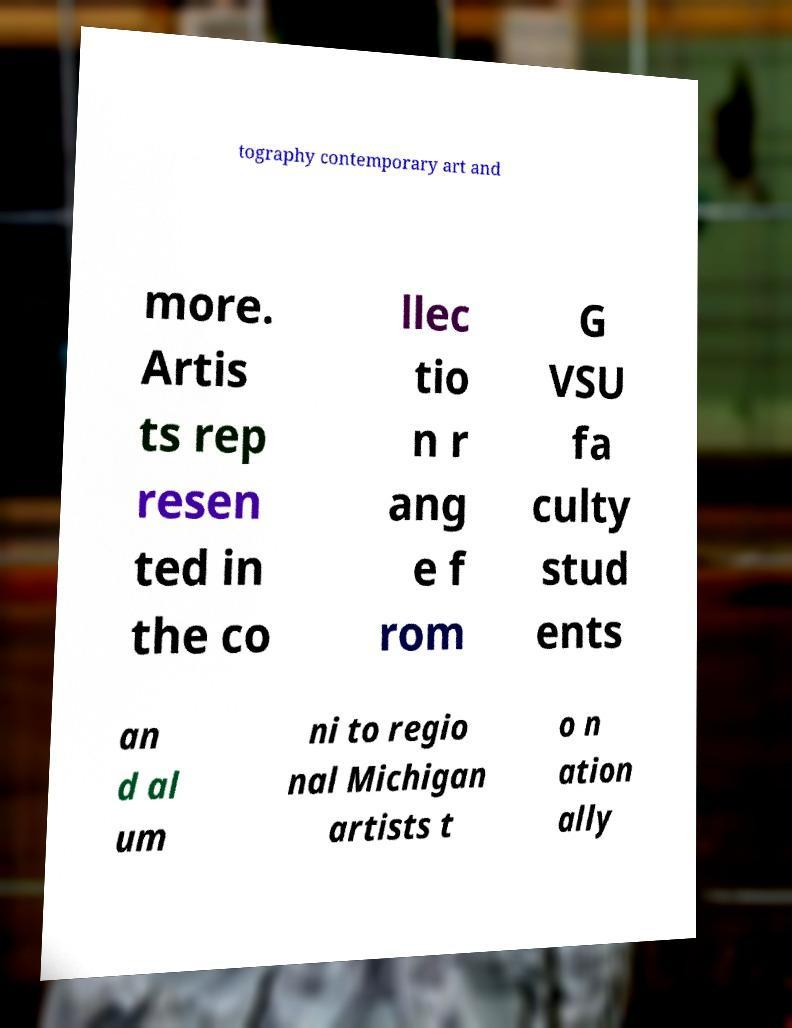Can you accurately transcribe the text from the provided image for me? tography contemporary art and more. Artis ts rep resen ted in the co llec tio n r ang e f rom G VSU fa culty stud ents an d al um ni to regio nal Michigan artists t o n ation ally 